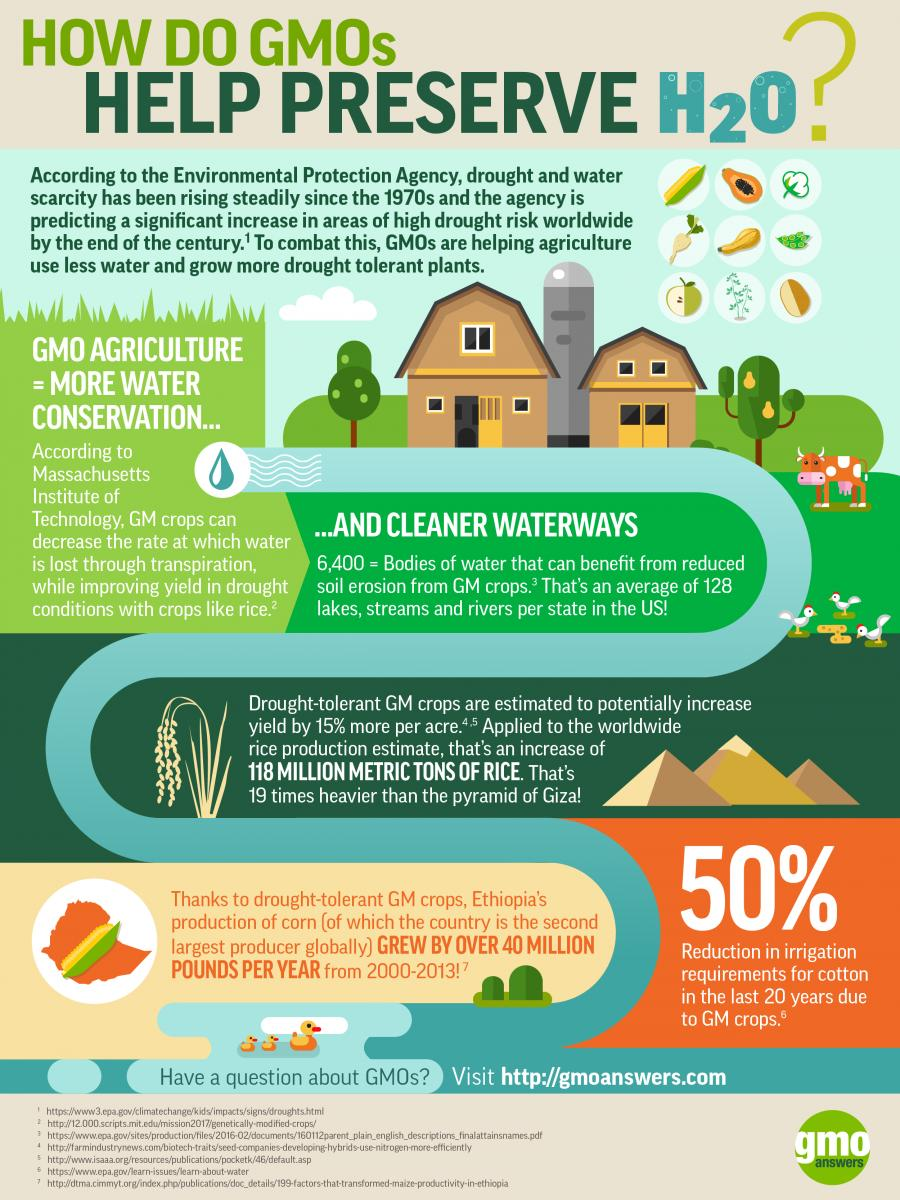Mention a couple of crucial points in this snapshot. The chemical formula for water is H2O, which means that it is composed of two atoms of hydrogen and one atom of oxygen. Genetically Modified Organisms (GMOs) in agriculture have the potential to increase water conservation efforts. Ethiopia is the second largest producer of corn in the world. Genetically Modified Organisms, also known as GMOs, are organisms that have been altered at the genetic level through the use of biotechnology. 